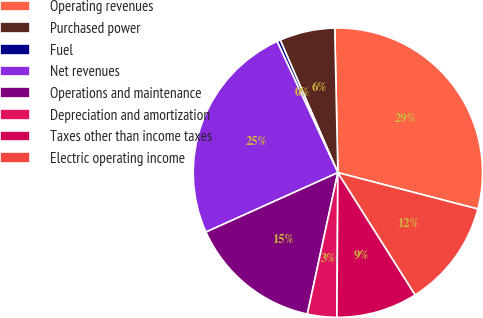<chart> <loc_0><loc_0><loc_500><loc_500><pie_chart><fcel>Operating revenues<fcel>Purchased power<fcel>Fuel<fcel>Net revenues<fcel>Operations and maintenance<fcel>Depreciation and amortization<fcel>Taxes other than income taxes<fcel>Electric operating income<nl><fcel>29.39%<fcel>6.18%<fcel>0.38%<fcel>24.83%<fcel>14.88%<fcel>3.28%<fcel>9.08%<fcel>11.98%<nl></chart> 